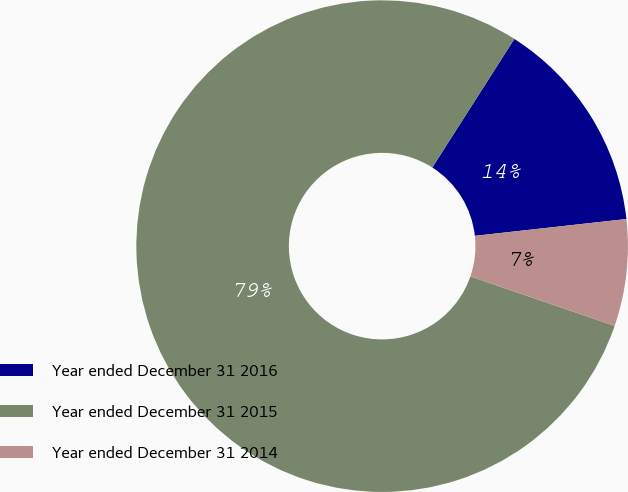Convert chart. <chart><loc_0><loc_0><loc_500><loc_500><pie_chart><fcel>Year ended December 31 2016<fcel>Year ended December 31 2015<fcel>Year ended December 31 2014<nl><fcel>14.2%<fcel>78.78%<fcel>7.02%<nl></chart> 